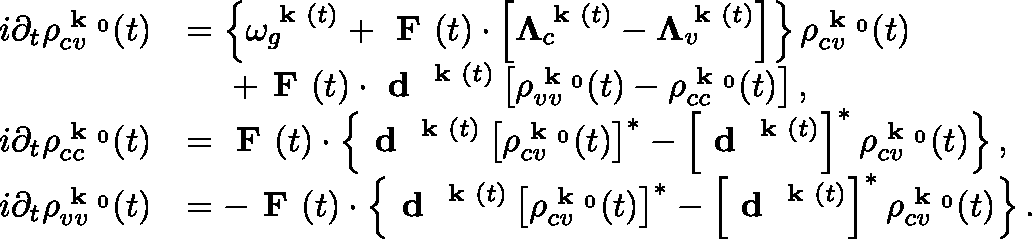<formula> <loc_0><loc_0><loc_500><loc_500>\begin{array} { r l } { i \partial _ { t } \rho _ { c v } ^ { k _ { 0 } } ( t ) } & { = \left \{ \omega _ { g } ^ { k ( t ) } + F ( t ) \cdot \left [ \Lambda _ { c } ^ { k ( t ) } - \Lambda _ { v } ^ { k ( t ) } \right ] \right \} \rho _ { c v } ^ { k _ { 0 } } ( t ) } \\ & { \quad + F ( t ) \cdot d ^ { k ( t ) } \left [ \rho _ { v v } ^ { k _ { 0 } } ( t ) - \rho _ { c c } ^ { k _ { 0 } } ( t ) \right ] , } \\ { i \partial _ { t } \rho _ { c c } ^ { k _ { 0 } } ( t ) } & { = F ( t ) \cdot \left \{ d ^ { k ( t ) } \left [ \rho _ { c v } ^ { k _ { 0 } } ( t ) \right ] ^ { * } - \left [ d ^ { k ( t ) } \right ] ^ { * } \rho _ { c v } ^ { k _ { 0 } } ( t ) \right \} , } \\ { i \partial _ { t } \rho _ { v v } ^ { k _ { 0 } } ( t ) } & { = - F ( t ) \cdot \left \{ d ^ { k ( t ) } \left [ \rho _ { c v } ^ { k _ { 0 } } ( t ) \right ] ^ { * } - \left [ d ^ { k ( t ) } \right ] ^ { * } \rho _ { c v } ^ { k _ { 0 } } ( t ) \right \} . } \end{array}</formula> 